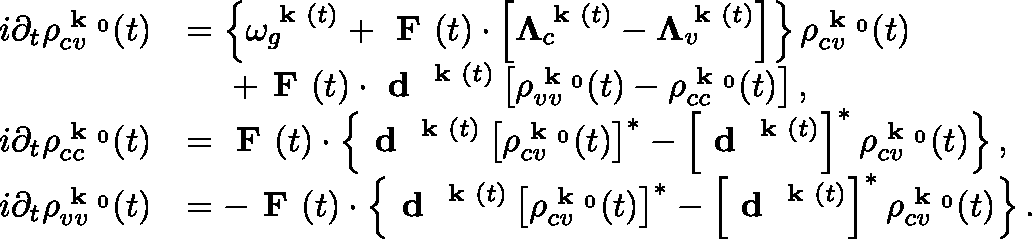<formula> <loc_0><loc_0><loc_500><loc_500>\begin{array} { r l } { i \partial _ { t } \rho _ { c v } ^ { k _ { 0 } } ( t ) } & { = \left \{ \omega _ { g } ^ { k ( t ) } + F ( t ) \cdot \left [ \Lambda _ { c } ^ { k ( t ) } - \Lambda _ { v } ^ { k ( t ) } \right ] \right \} \rho _ { c v } ^ { k _ { 0 } } ( t ) } \\ & { \quad + F ( t ) \cdot d ^ { k ( t ) } \left [ \rho _ { v v } ^ { k _ { 0 } } ( t ) - \rho _ { c c } ^ { k _ { 0 } } ( t ) \right ] , } \\ { i \partial _ { t } \rho _ { c c } ^ { k _ { 0 } } ( t ) } & { = F ( t ) \cdot \left \{ d ^ { k ( t ) } \left [ \rho _ { c v } ^ { k _ { 0 } } ( t ) \right ] ^ { * } - \left [ d ^ { k ( t ) } \right ] ^ { * } \rho _ { c v } ^ { k _ { 0 } } ( t ) \right \} , } \\ { i \partial _ { t } \rho _ { v v } ^ { k _ { 0 } } ( t ) } & { = - F ( t ) \cdot \left \{ d ^ { k ( t ) } \left [ \rho _ { c v } ^ { k _ { 0 } } ( t ) \right ] ^ { * } - \left [ d ^ { k ( t ) } \right ] ^ { * } \rho _ { c v } ^ { k _ { 0 } } ( t ) \right \} . } \end{array}</formula> 